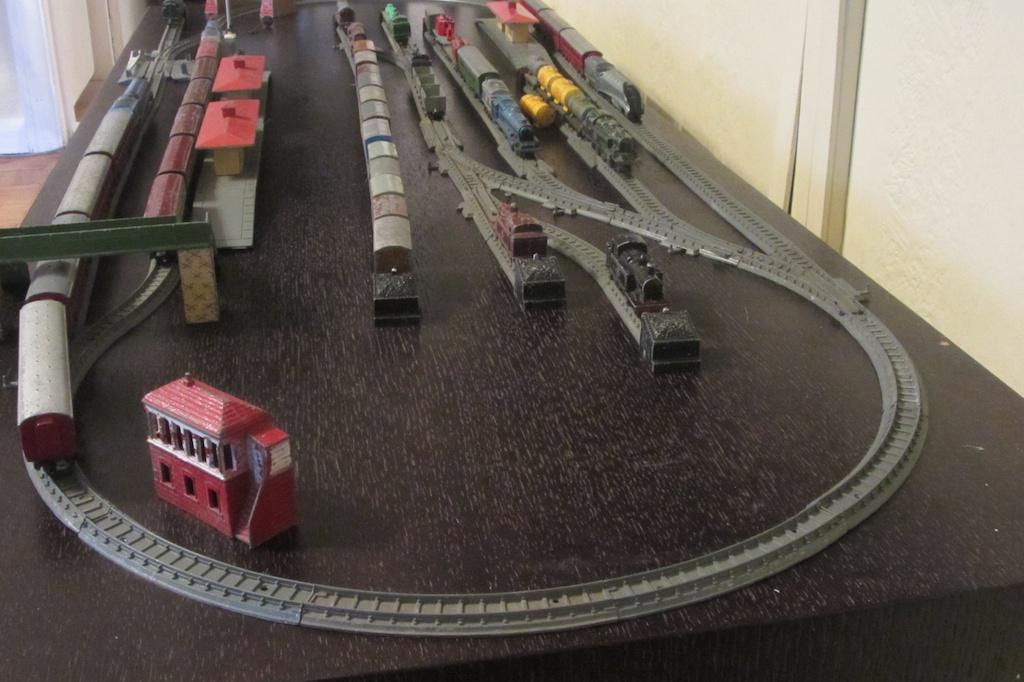Can you describe this image briefly? In this image we can see the toy trains and toy railway tracks. In the background there are walls. 